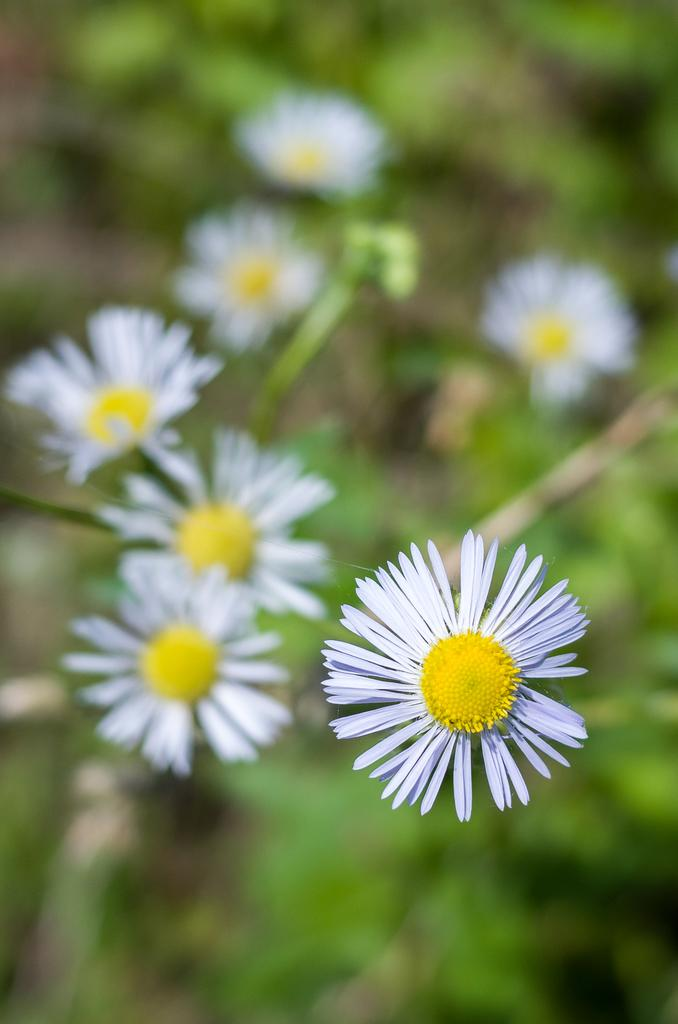What is the main subject of the image? The main subject of the image is many flowers. Where are the flowers located? The flowers are on plants. What type of shop can be seen in the background of the image? There is no shop present in the image; it only features many flowers on plants. 